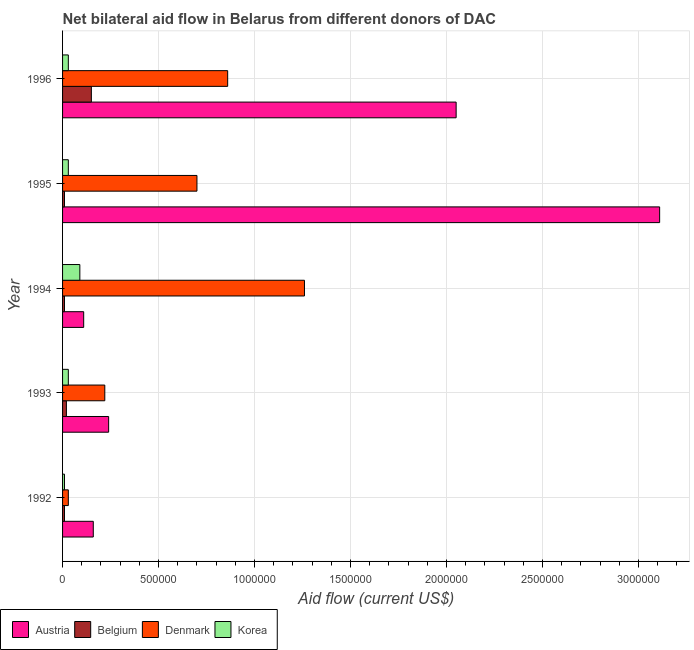How many different coloured bars are there?
Give a very brief answer. 4. How many bars are there on the 5th tick from the top?
Give a very brief answer. 4. In how many cases, is the number of bars for a given year not equal to the number of legend labels?
Your answer should be very brief. 0. What is the amount of aid given by belgium in 1993?
Make the answer very short. 2.00e+04. Across all years, what is the maximum amount of aid given by belgium?
Make the answer very short. 1.50e+05. Across all years, what is the minimum amount of aid given by austria?
Make the answer very short. 1.10e+05. In which year was the amount of aid given by belgium minimum?
Offer a very short reply. 1992. What is the total amount of aid given by denmark in the graph?
Offer a very short reply. 3.07e+06. What is the difference between the amount of aid given by austria in 1992 and that in 1993?
Offer a terse response. -8.00e+04. What is the difference between the amount of aid given by korea in 1993 and the amount of aid given by denmark in 1996?
Ensure brevity in your answer.  -8.30e+05. What is the average amount of aid given by denmark per year?
Your response must be concise. 6.14e+05. In the year 1995, what is the difference between the amount of aid given by belgium and amount of aid given by denmark?
Your answer should be very brief. -6.90e+05. In how many years, is the amount of aid given by belgium greater than 600000 US$?
Offer a very short reply. 0. What is the ratio of the amount of aid given by denmark in 1992 to that in 1995?
Ensure brevity in your answer.  0.04. Is the amount of aid given by austria in 1992 less than that in 1993?
Offer a very short reply. Yes. What is the difference between the highest and the second highest amount of aid given by belgium?
Your answer should be very brief. 1.30e+05. What is the difference between the highest and the lowest amount of aid given by belgium?
Keep it short and to the point. 1.40e+05. In how many years, is the amount of aid given by belgium greater than the average amount of aid given by belgium taken over all years?
Ensure brevity in your answer.  1. Is the sum of the amount of aid given by denmark in 1993 and 1994 greater than the maximum amount of aid given by korea across all years?
Offer a very short reply. Yes. Is it the case that in every year, the sum of the amount of aid given by korea and amount of aid given by denmark is greater than the sum of amount of aid given by belgium and amount of aid given by austria?
Make the answer very short. No. What does the 2nd bar from the bottom in 1992 represents?
Offer a terse response. Belgium. Is it the case that in every year, the sum of the amount of aid given by austria and amount of aid given by belgium is greater than the amount of aid given by denmark?
Ensure brevity in your answer.  No. How many years are there in the graph?
Give a very brief answer. 5. What is the difference between two consecutive major ticks on the X-axis?
Your response must be concise. 5.00e+05. Are the values on the major ticks of X-axis written in scientific E-notation?
Make the answer very short. No. How many legend labels are there?
Give a very brief answer. 4. How are the legend labels stacked?
Offer a terse response. Horizontal. What is the title of the graph?
Ensure brevity in your answer.  Net bilateral aid flow in Belarus from different donors of DAC. What is the label or title of the X-axis?
Your answer should be compact. Aid flow (current US$). What is the label or title of the Y-axis?
Your answer should be very brief. Year. What is the Aid flow (current US$) of Korea in 1992?
Ensure brevity in your answer.  10000. What is the Aid flow (current US$) in Belgium in 1993?
Your answer should be compact. 2.00e+04. What is the Aid flow (current US$) in Denmark in 1994?
Give a very brief answer. 1.26e+06. What is the Aid flow (current US$) of Korea in 1994?
Your answer should be compact. 9.00e+04. What is the Aid flow (current US$) of Austria in 1995?
Your answer should be very brief. 3.11e+06. What is the Aid flow (current US$) of Austria in 1996?
Your answer should be very brief. 2.05e+06. What is the Aid flow (current US$) of Belgium in 1996?
Offer a terse response. 1.50e+05. What is the Aid flow (current US$) of Denmark in 1996?
Your answer should be compact. 8.60e+05. What is the Aid flow (current US$) in Korea in 1996?
Keep it short and to the point. 3.00e+04. Across all years, what is the maximum Aid flow (current US$) of Austria?
Provide a succinct answer. 3.11e+06. Across all years, what is the maximum Aid flow (current US$) in Belgium?
Provide a succinct answer. 1.50e+05. Across all years, what is the maximum Aid flow (current US$) of Denmark?
Your response must be concise. 1.26e+06. Across all years, what is the minimum Aid flow (current US$) in Austria?
Give a very brief answer. 1.10e+05. Across all years, what is the minimum Aid flow (current US$) in Belgium?
Give a very brief answer. 10000. Across all years, what is the minimum Aid flow (current US$) in Korea?
Offer a terse response. 10000. What is the total Aid flow (current US$) in Austria in the graph?
Your answer should be compact. 5.67e+06. What is the total Aid flow (current US$) of Denmark in the graph?
Your answer should be very brief. 3.07e+06. What is the total Aid flow (current US$) in Korea in the graph?
Offer a very short reply. 1.90e+05. What is the difference between the Aid flow (current US$) in Korea in 1992 and that in 1993?
Your answer should be very brief. -2.00e+04. What is the difference between the Aid flow (current US$) of Austria in 1992 and that in 1994?
Make the answer very short. 5.00e+04. What is the difference between the Aid flow (current US$) of Denmark in 1992 and that in 1994?
Your answer should be very brief. -1.23e+06. What is the difference between the Aid flow (current US$) of Austria in 1992 and that in 1995?
Ensure brevity in your answer.  -2.95e+06. What is the difference between the Aid flow (current US$) of Belgium in 1992 and that in 1995?
Ensure brevity in your answer.  0. What is the difference between the Aid flow (current US$) in Denmark in 1992 and that in 1995?
Keep it short and to the point. -6.70e+05. What is the difference between the Aid flow (current US$) of Austria in 1992 and that in 1996?
Ensure brevity in your answer.  -1.89e+06. What is the difference between the Aid flow (current US$) of Belgium in 1992 and that in 1996?
Make the answer very short. -1.40e+05. What is the difference between the Aid flow (current US$) of Denmark in 1992 and that in 1996?
Your response must be concise. -8.30e+05. What is the difference between the Aid flow (current US$) in Korea in 1992 and that in 1996?
Keep it short and to the point. -2.00e+04. What is the difference between the Aid flow (current US$) of Austria in 1993 and that in 1994?
Your answer should be very brief. 1.30e+05. What is the difference between the Aid flow (current US$) in Denmark in 1993 and that in 1994?
Offer a terse response. -1.04e+06. What is the difference between the Aid flow (current US$) in Austria in 1993 and that in 1995?
Your answer should be compact. -2.87e+06. What is the difference between the Aid flow (current US$) in Denmark in 1993 and that in 1995?
Provide a short and direct response. -4.80e+05. What is the difference between the Aid flow (current US$) in Korea in 1993 and that in 1995?
Give a very brief answer. 0. What is the difference between the Aid flow (current US$) of Austria in 1993 and that in 1996?
Your answer should be compact. -1.81e+06. What is the difference between the Aid flow (current US$) of Denmark in 1993 and that in 1996?
Provide a short and direct response. -6.40e+05. What is the difference between the Aid flow (current US$) of Denmark in 1994 and that in 1995?
Give a very brief answer. 5.60e+05. What is the difference between the Aid flow (current US$) in Korea in 1994 and that in 1995?
Your answer should be very brief. 6.00e+04. What is the difference between the Aid flow (current US$) in Austria in 1994 and that in 1996?
Provide a short and direct response. -1.94e+06. What is the difference between the Aid flow (current US$) in Korea in 1994 and that in 1996?
Provide a short and direct response. 6.00e+04. What is the difference between the Aid flow (current US$) in Austria in 1995 and that in 1996?
Your response must be concise. 1.06e+06. What is the difference between the Aid flow (current US$) of Belgium in 1992 and the Aid flow (current US$) of Denmark in 1993?
Keep it short and to the point. -2.10e+05. What is the difference between the Aid flow (current US$) in Belgium in 1992 and the Aid flow (current US$) in Korea in 1993?
Make the answer very short. -2.00e+04. What is the difference between the Aid flow (current US$) of Austria in 1992 and the Aid flow (current US$) of Belgium in 1994?
Offer a very short reply. 1.50e+05. What is the difference between the Aid flow (current US$) of Austria in 1992 and the Aid flow (current US$) of Denmark in 1994?
Keep it short and to the point. -1.10e+06. What is the difference between the Aid flow (current US$) in Austria in 1992 and the Aid flow (current US$) in Korea in 1994?
Your response must be concise. 7.00e+04. What is the difference between the Aid flow (current US$) in Belgium in 1992 and the Aid flow (current US$) in Denmark in 1994?
Give a very brief answer. -1.25e+06. What is the difference between the Aid flow (current US$) of Denmark in 1992 and the Aid flow (current US$) of Korea in 1994?
Keep it short and to the point. -6.00e+04. What is the difference between the Aid flow (current US$) in Austria in 1992 and the Aid flow (current US$) in Belgium in 1995?
Offer a terse response. 1.50e+05. What is the difference between the Aid flow (current US$) of Austria in 1992 and the Aid flow (current US$) of Denmark in 1995?
Offer a very short reply. -5.40e+05. What is the difference between the Aid flow (current US$) in Austria in 1992 and the Aid flow (current US$) in Korea in 1995?
Provide a short and direct response. 1.30e+05. What is the difference between the Aid flow (current US$) of Belgium in 1992 and the Aid flow (current US$) of Denmark in 1995?
Offer a terse response. -6.90e+05. What is the difference between the Aid flow (current US$) of Austria in 1992 and the Aid flow (current US$) of Belgium in 1996?
Offer a terse response. 10000. What is the difference between the Aid flow (current US$) in Austria in 1992 and the Aid flow (current US$) in Denmark in 1996?
Give a very brief answer. -7.00e+05. What is the difference between the Aid flow (current US$) of Belgium in 1992 and the Aid flow (current US$) of Denmark in 1996?
Offer a terse response. -8.50e+05. What is the difference between the Aid flow (current US$) in Austria in 1993 and the Aid flow (current US$) in Denmark in 1994?
Keep it short and to the point. -1.02e+06. What is the difference between the Aid flow (current US$) of Austria in 1993 and the Aid flow (current US$) of Korea in 1994?
Your response must be concise. 1.50e+05. What is the difference between the Aid flow (current US$) in Belgium in 1993 and the Aid flow (current US$) in Denmark in 1994?
Offer a very short reply. -1.24e+06. What is the difference between the Aid flow (current US$) of Austria in 1993 and the Aid flow (current US$) of Belgium in 1995?
Provide a short and direct response. 2.30e+05. What is the difference between the Aid flow (current US$) of Austria in 1993 and the Aid flow (current US$) of Denmark in 1995?
Offer a very short reply. -4.60e+05. What is the difference between the Aid flow (current US$) in Austria in 1993 and the Aid flow (current US$) in Korea in 1995?
Your answer should be very brief. 2.10e+05. What is the difference between the Aid flow (current US$) in Belgium in 1993 and the Aid flow (current US$) in Denmark in 1995?
Provide a short and direct response. -6.80e+05. What is the difference between the Aid flow (current US$) in Denmark in 1993 and the Aid flow (current US$) in Korea in 1995?
Make the answer very short. 1.90e+05. What is the difference between the Aid flow (current US$) of Austria in 1993 and the Aid flow (current US$) of Denmark in 1996?
Provide a short and direct response. -6.20e+05. What is the difference between the Aid flow (current US$) in Belgium in 1993 and the Aid flow (current US$) in Denmark in 1996?
Provide a succinct answer. -8.40e+05. What is the difference between the Aid flow (current US$) in Belgium in 1993 and the Aid flow (current US$) in Korea in 1996?
Offer a very short reply. -10000. What is the difference between the Aid flow (current US$) in Denmark in 1993 and the Aid flow (current US$) in Korea in 1996?
Your response must be concise. 1.90e+05. What is the difference between the Aid flow (current US$) of Austria in 1994 and the Aid flow (current US$) of Denmark in 1995?
Provide a short and direct response. -5.90e+05. What is the difference between the Aid flow (current US$) in Austria in 1994 and the Aid flow (current US$) in Korea in 1995?
Your answer should be compact. 8.00e+04. What is the difference between the Aid flow (current US$) of Belgium in 1994 and the Aid flow (current US$) of Denmark in 1995?
Ensure brevity in your answer.  -6.90e+05. What is the difference between the Aid flow (current US$) in Denmark in 1994 and the Aid flow (current US$) in Korea in 1995?
Your response must be concise. 1.23e+06. What is the difference between the Aid flow (current US$) in Austria in 1994 and the Aid flow (current US$) in Belgium in 1996?
Offer a terse response. -4.00e+04. What is the difference between the Aid flow (current US$) of Austria in 1994 and the Aid flow (current US$) of Denmark in 1996?
Make the answer very short. -7.50e+05. What is the difference between the Aid flow (current US$) in Austria in 1994 and the Aid flow (current US$) in Korea in 1996?
Provide a short and direct response. 8.00e+04. What is the difference between the Aid flow (current US$) of Belgium in 1994 and the Aid flow (current US$) of Denmark in 1996?
Your answer should be compact. -8.50e+05. What is the difference between the Aid flow (current US$) of Belgium in 1994 and the Aid flow (current US$) of Korea in 1996?
Ensure brevity in your answer.  -2.00e+04. What is the difference between the Aid flow (current US$) in Denmark in 1994 and the Aid flow (current US$) in Korea in 1996?
Your answer should be very brief. 1.23e+06. What is the difference between the Aid flow (current US$) of Austria in 1995 and the Aid flow (current US$) of Belgium in 1996?
Keep it short and to the point. 2.96e+06. What is the difference between the Aid flow (current US$) in Austria in 1995 and the Aid flow (current US$) in Denmark in 1996?
Your answer should be compact. 2.25e+06. What is the difference between the Aid flow (current US$) of Austria in 1995 and the Aid flow (current US$) of Korea in 1996?
Your response must be concise. 3.08e+06. What is the difference between the Aid flow (current US$) of Belgium in 1995 and the Aid flow (current US$) of Denmark in 1996?
Provide a short and direct response. -8.50e+05. What is the difference between the Aid flow (current US$) in Belgium in 1995 and the Aid flow (current US$) in Korea in 1996?
Provide a short and direct response. -2.00e+04. What is the difference between the Aid flow (current US$) of Denmark in 1995 and the Aid flow (current US$) of Korea in 1996?
Offer a very short reply. 6.70e+05. What is the average Aid flow (current US$) of Austria per year?
Your response must be concise. 1.13e+06. What is the average Aid flow (current US$) in Denmark per year?
Your answer should be very brief. 6.14e+05. What is the average Aid flow (current US$) in Korea per year?
Make the answer very short. 3.80e+04. In the year 1992, what is the difference between the Aid flow (current US$) of Austria and Aid flow (current US$) of Belgium?
Provide a succinct answer. 1.50e+05. In the year 1992, what is the difference between the Aid flow (current US$) of Belgium and Aid flow (current US$) of Denmark?
Provide a succinct answer. -2.00e+04. In the year 1993, what is the difference between the Aid flow (current US$) of Austria and Aid flow (current US$) of Belgium?
Ensure brevity in your answer.  2.20e+05. In the year 1993, what is the difference between the Aid flow (current US$) in Austria and Aid flow (current US$) in Denmark?
Make the answer very short. 2.00e+04. In the year 1993, what is the difference between the Aid flow (current US$) in Austria and Aid flow (current US$) in Korea?
Provide a succinct answer. 2.10e+05. In the year 1993, what is the difference between the Aid flow (current US$) of Belgium and Aid flow (current US$) of Denmark?
Offer a very short reply. -2.00e+05. In the year 1993, what is the difference between the Aid flow (current US$) in Belgium and Aid flow (current US$) in Korea?
Offer a very short reply. -10000. In the year 1993, what is the difference between the Aid flow (current US$) of Denmark and Aid flow (current US$) of Korea?
Your answer should be compact. 1.90e+05. In the year 1994, what is the difference between the Aid flow (current US$) in Austria and Aid flow (current US$) in Belgium?
Your response must be concise. 1.00e+05. In the year 1994, what is the difference between the Aid flow (current US$) in Austria and Aid flow (current US$) in Denmark?
Make the answer very short. -1.15e+06. In the year 1994, what is the difference between the Aid flow (current US$) in Belgium and Aid flow (current US$) in Denmark?
Provide a short and direct response. -1.25e+06. In the year 1994, what is the difference between the Aid flow (current US$) in Denmark and Aid flow (current US$) in Korea?
Ensure brevity in your answer.  1.17e+06. In the year 1995, what is the difference between the Aid flow (current US$) of Austria and Aid flow (current US$) of Belgium?
Offer a very short reply. 3.10e+06. In the year 1995, what is the difference between the Aid flow (current US$) of Austria and Aid flow (current US$) of Denmark?
Keep it short and to the point. 2.41e+06. In the year 1995, what is the difference between the Aid flow (current US$) of Austria and Aid flow (current US$) of Korea?
Offer a very short reply. 3.08e+06. In the year 1995, what is the difference between the Aid flow (current US$) of Belgium and Aid flow (current US$) of Denmark?
Provide a succinct answer. -6.90e+05. In the year 1995, what is the difference between the Aid flow (current US$) in Denmark and Aid flow (current US$) in Korea?
Ensure brevity in your answer.  6.70e+05. In the year 1996, what is the difference between the Aid flow (current US$) of Austria and Aid flow (current US$) of Belgium?
Provide a succinct answer. 1.90e+06. In the year 1996, what is the difference between the Aid flow (current US$) of Austria and Aid flow (current US$) of Denmark?
Your answer should be compact. 1.19e+06. In the year 1996, what is the difference between the Aid flow (current US$) of Austria and Aid flow (current US$) of Korea?
Keep it short and to the point. 2.02e+06. In the year 1996, what is the difference between the Aid flow (current US$) of Belgium and Aid flow (current US$) of Denmark?
Your answer should be compact. -7.10e+05. In the year 1996, what is the difference between the Aid flow (current US$) of Denmark and Aid flow (current US$) of Korea?
Your answer should be compact. 8.30e+05. What is the ratio of the Aid flow (current US$) of Austria in 1992 to that in 1993?
Provide a succinct answer. 0.67. What is the ratio of the Aid flow (current US$) of Denmark in 1992 to that in 1993?
Offer a terse response. 0.14. What is the ratio of the Aid flow (current US$) of Korea in 1992 to that in 1993?
Make the answer very short. 0.33. What is the ratio of the Aid flow (current US$) of Austria in 1992 to that in 1994?
Provide a short and direct response. 1.45. What is the ratio of the Aid flow (current US$) of Denmark in 1992 to that in 1994?
Offer a terse response. 0.02. What is the ratio of the Aid flow (current US$) of Korea in 1992 to that in 1994?
Your answer should be very brief. 0.11. What is the ratio of the Aid flow (current US$) in Austria in 1992 to that in 1995?
Offer a terse response. 0.05. What is the ratio of the Aid flow (current US$) of Belgium in 1992 to that in 1995?
Your answer should be very brief. 1. What is the ratio of the Aid flow (current US$) in Denmark in 1992 to that in 1995?
Give a very brief answer. 0.04. What is the ratio of the Aid flow (current US$) in Korea in 1992 to that in 1995?
Provide a succinct answer. 0.33. What is the ratio of the Aid flow (current US$) of Austria in 1992 to that in 1996?
Ensure brevity in your answer.  0.08. What is the ratio of the Aid flow (current US$) of Belgium in 1992 to that in 1996?
Provide a succinct answer. 0.07. What is the ratio of the Aid flow (current US$) in Denmark in 1992 to that in 1996?
Ensure brevity in your answer.  0.03. What is the ratio of the Aid flow (current US$) in Austria in 1993 to that in 1994?
Provide a short and direct response. 2.18. What is the ratio of the Aid flow (current US$) of Belgium in 1993 to that in 1994?
Ensure brevity in your answer.  2. What is the ratio of the Aid flow (current US$) in Denmark in 1993 to that in 1994?
Offer a terse response. 0.17. What is the ratio of the Aid flow (current US$) in Korea in 1993 to that in 1994?
Give a very brief answer. 0.33. What is the ratio of the Aid flow (current US$) in Austria in 1993 to that in 1995?
Give a very brief answer. 0.08. What is the ratio of the Aid flow (current US$) of Belgium in 1993 to that in 1995?
Offer a very short reply. 2. What is the ratio of the Aid flow (current US$) of Denmark in 1993 to that in 1995?
Make the answer very short. 0.31. What is the ratio of the Aid flow (current US$) in Austria in 1993 to that in 1996?
Keep it short and to the point. 0.12. What is the ratio of the Aid flow (current US$) in Belgium in 1993 to that in 1996?
Offer a very short reply. 0.13. What is the ratio of the Aid flow (current US$) of Denmark in 1993 to that in 1996?
Your response must be concise. 0.26. What is the ratio of the Aid flow (current US$) of Korea in 1993 to that in 1996?
Offer a very short reply. 1. What is the ratio of the Aid flow (current US$) of Austria in 1994 to that in 1995?
Make the answer very short. 0.04. What is the ratio of the Aid flow (current US$) in Denmark in 1994 to that in 1995?
Your answer should be very brief. 1.8. What is the ratio of the Aid flow (current US$) in Austria in 1994 to that in 1996?
Ensure brevity in your answer.  0.05. What is the ratio of the Aid flow (current US$) of Belgium in 1994 to that in 1996?
Your answer should be compact. 0.07. What is the ratio of the Aid flow (current US$) in Denmark in 1994 to that in 1996?
Give a very brief answer. 1.47. What is the ratio of the Aid flow (current US$) of Austria in 1995 to that in 1996?
Keep it short and to the point. 1.52. What is the ratio of the Aid flow (current US$) of Belgium in 1995 to that in 1996?
Your response must be concise. 0.07. What is the ratio of the Aid flow (current US$) of Denmark in 1995 to that in 1996?
Make the answer very short. 0.81. What is the difference between the highest and the second highest Aid flow (current US$) in Austria?
Make the answer very short. 1.06e+06. What is the difference between the highest and the lowest Aid flow (current US$) of Austria?
Offer a terse response. 3.00e+06. What is the difference between the highest and the lowest Aid flow (current US$) in Belgium?
Offer a very short reply. 1.40e+05. What is the difference between the highest and the lowest Aid flow (current US$) of Denmark?
Provide a succinct answer. 1.23e+06. What is the difference between the highest and the lowest Aid flow (current US$) in Korea?
Keep it short and to the point. 8.00e+04. 